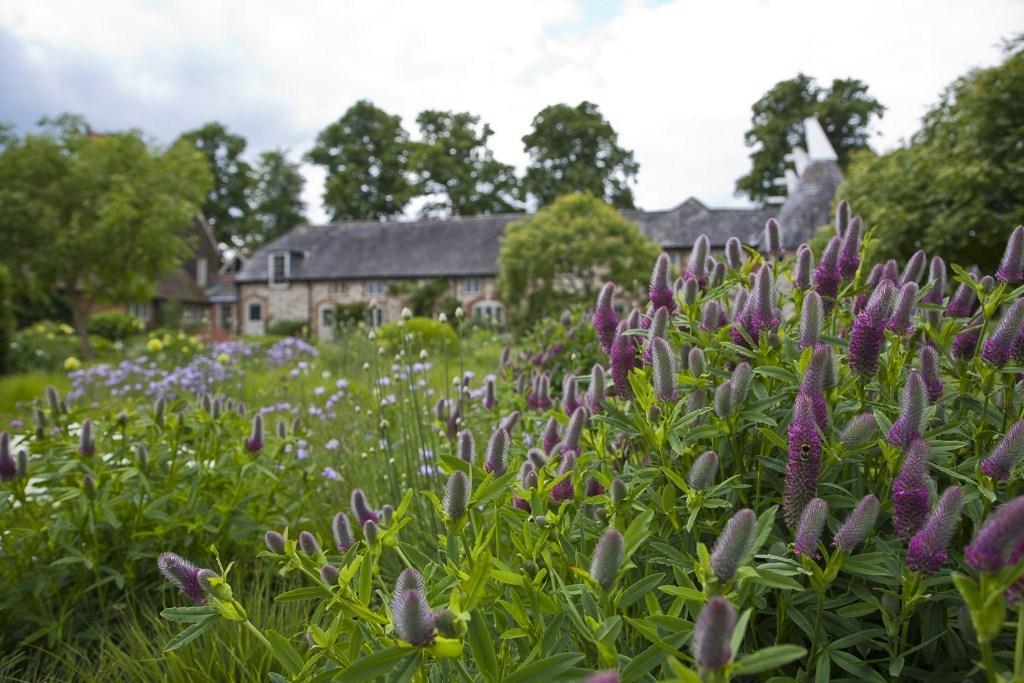How would you summarize this image in a sentence or two? In this image, at the bottom there are plants, flowers, buds, leaves. In the background there are trees, houseplants, sky and clouds. 